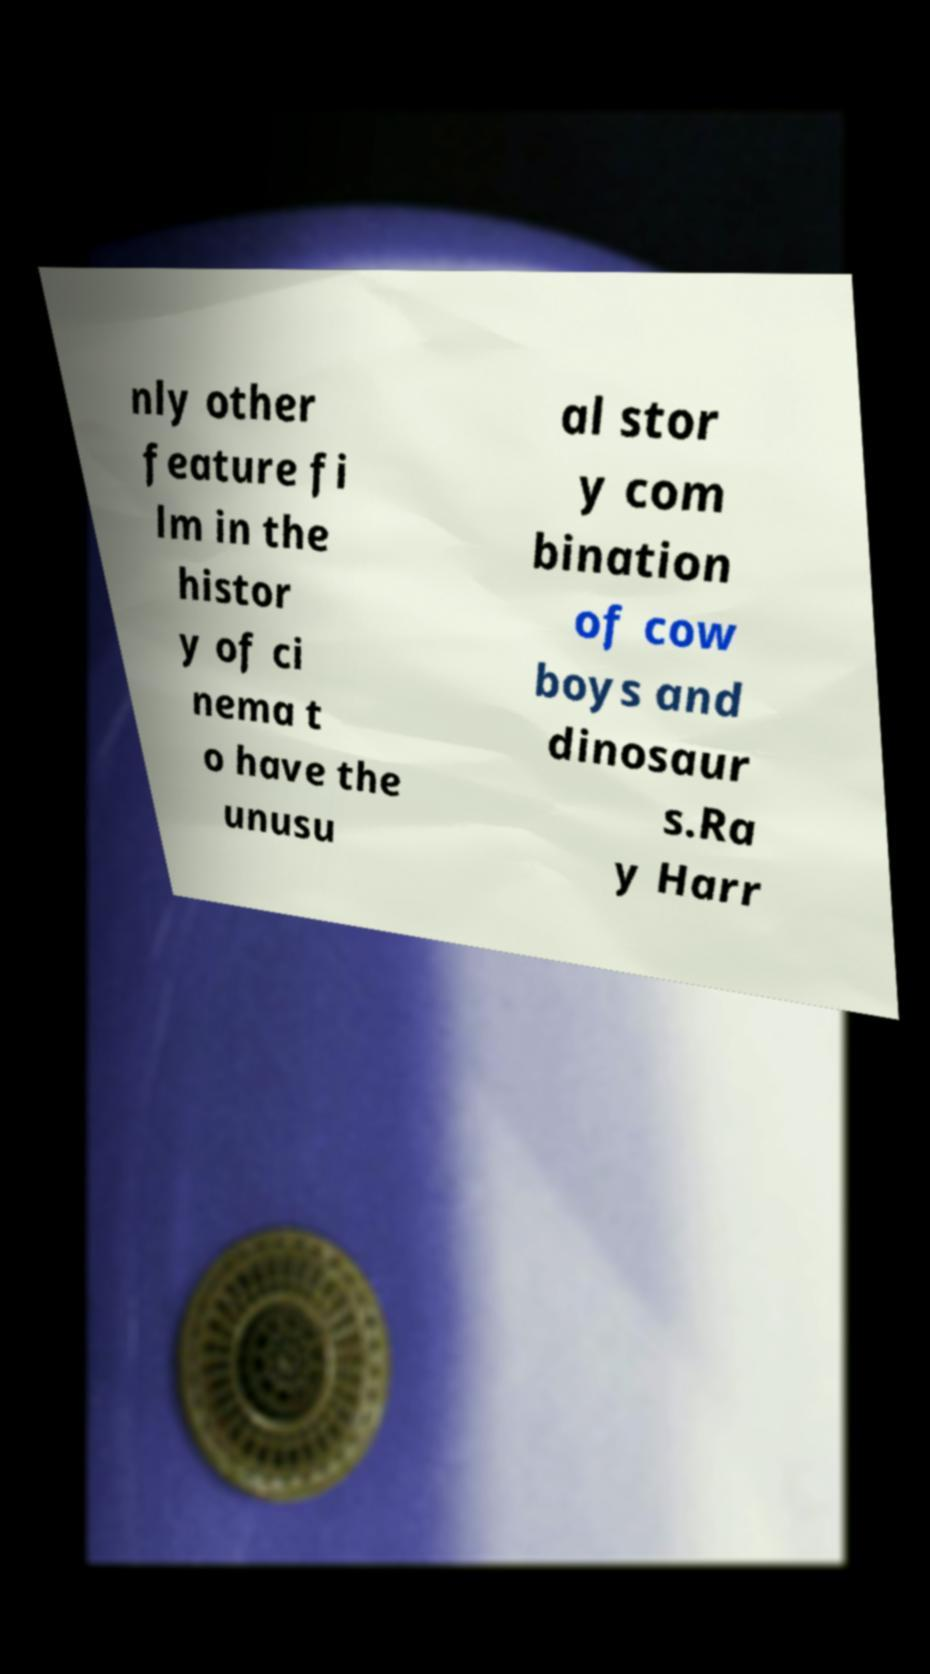Could you assist in decoding the text presented in this image and type it out clearly? nly other feature fi lm in the histor y of ci nema t o have the unusu al stor y com bination of cow boys and dinosaur s.Ra y Harr 